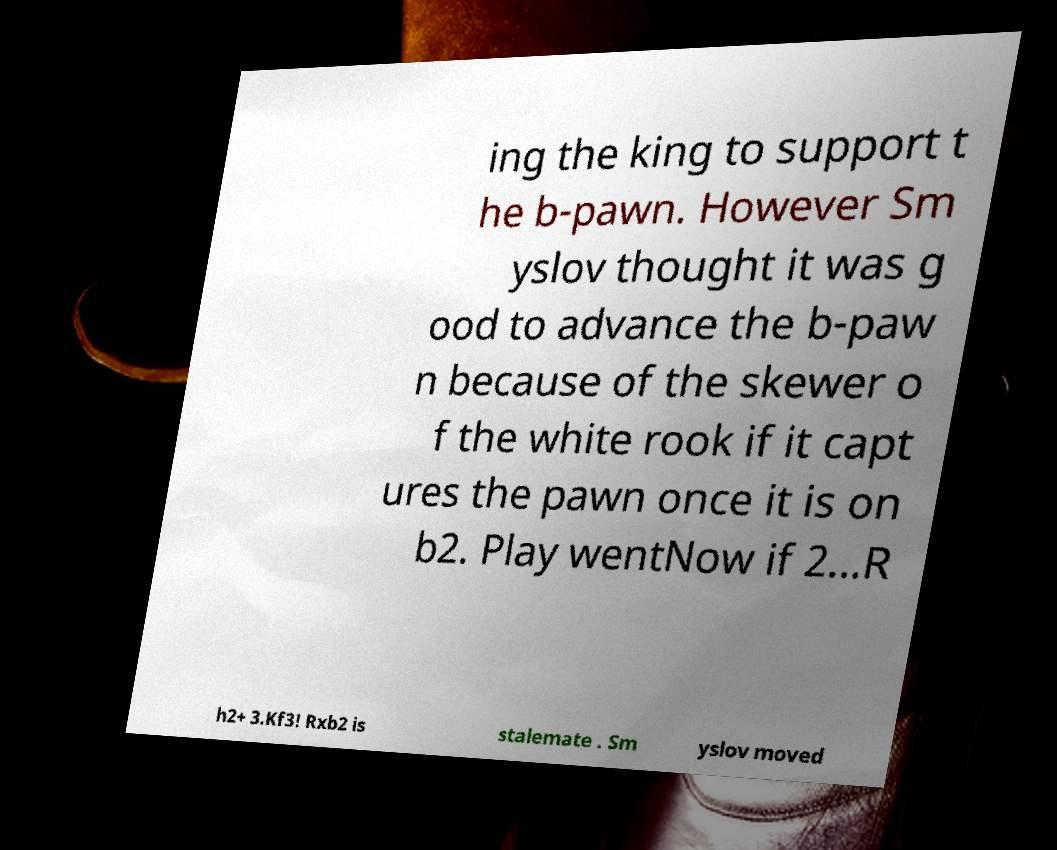Can you accurately transcribe the text from the provided image for me? ing the king to support t he b-pawn. However Sm yslov thought it was g ood to advance the b-paw n because of the skewer o f the white rook if it capt ures the pawn once it is on b2. Play wentNow if 2...R h2+ 3.Kf3! Rxb2 is stalemate . Sm yslov moved 